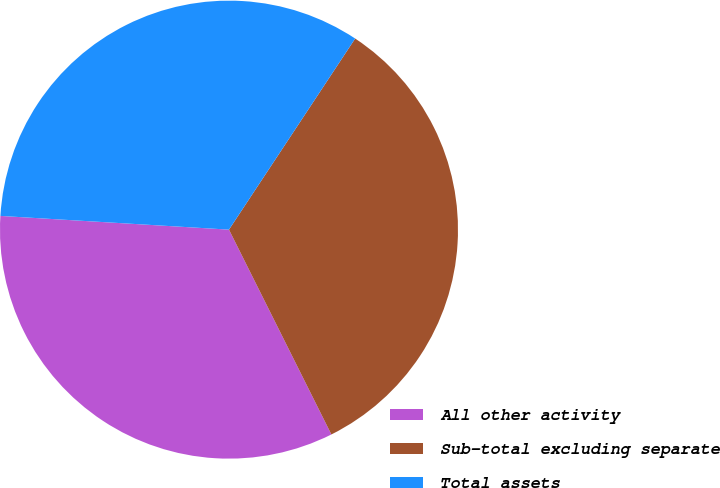<chart> <loc_0><loc_0><loc_500><loc_500><pie_chart><fcel>All other activity<fcel>Sub-total excluding separate<fcel>Total assets<nl><fcel>33.33%<fcel>33.33%<fcel>33.33%<nl></chart> 